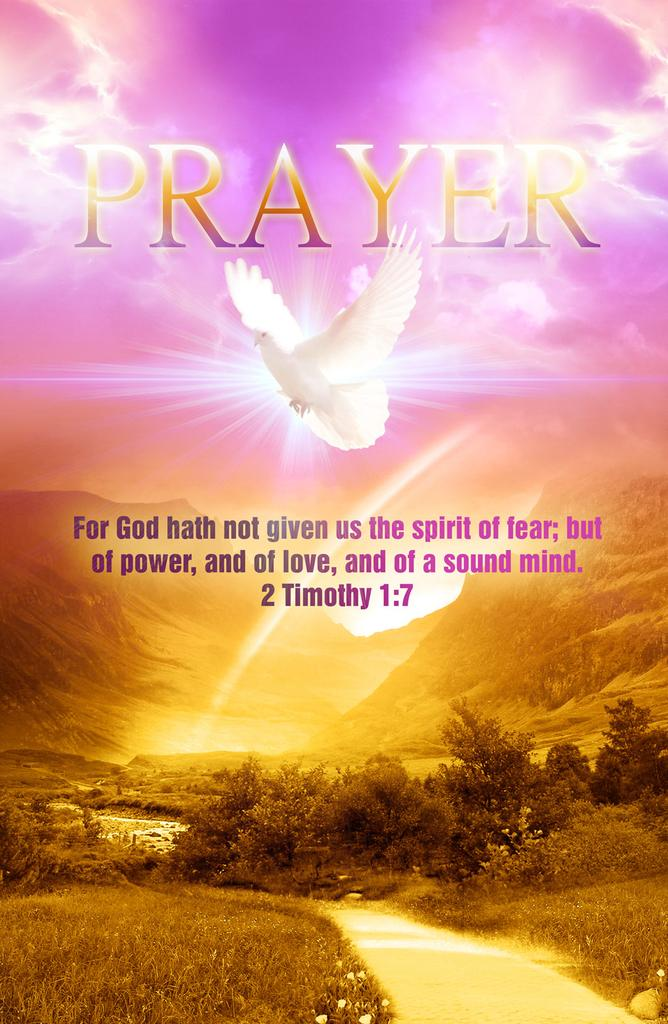<image>
Render a clear and concise summary of the photo. Poster that shows a dove and the word prayer above it. 